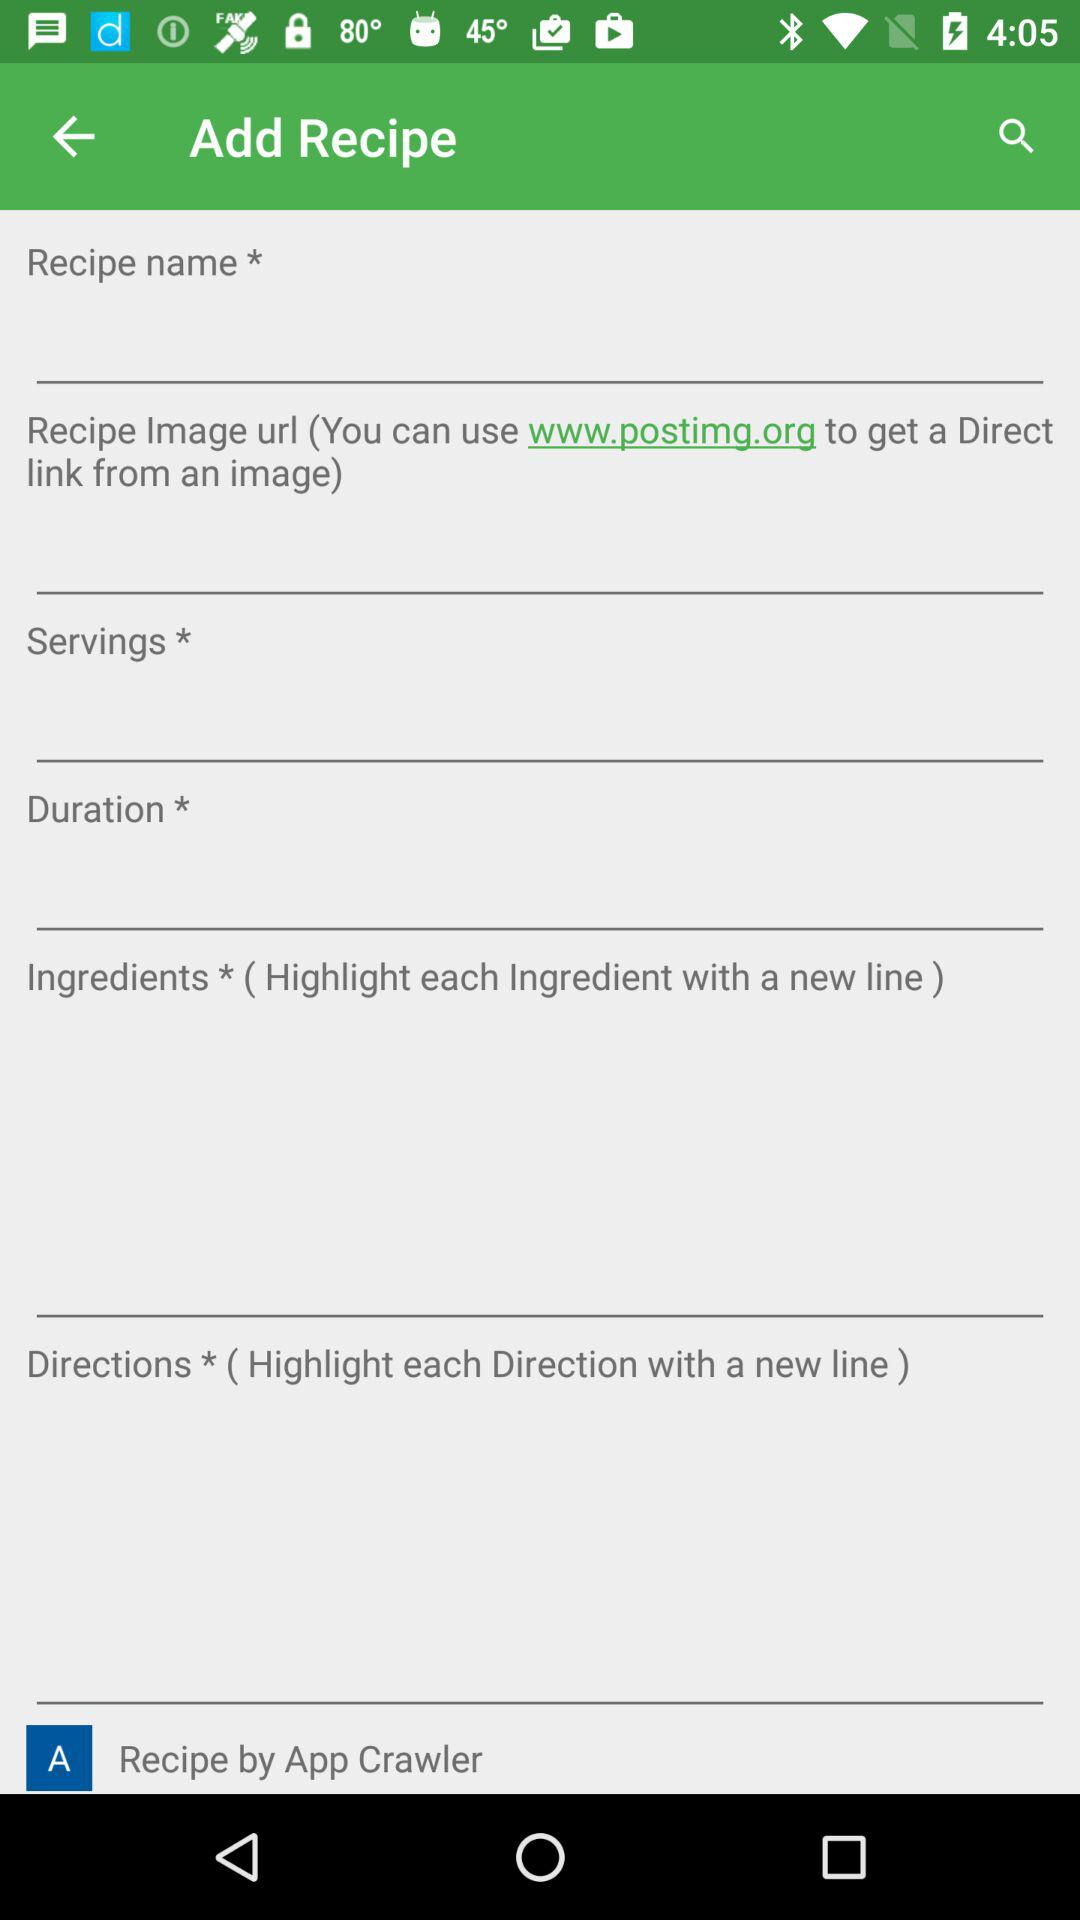What's the chef's name? The name of the chef is App Crawler. 